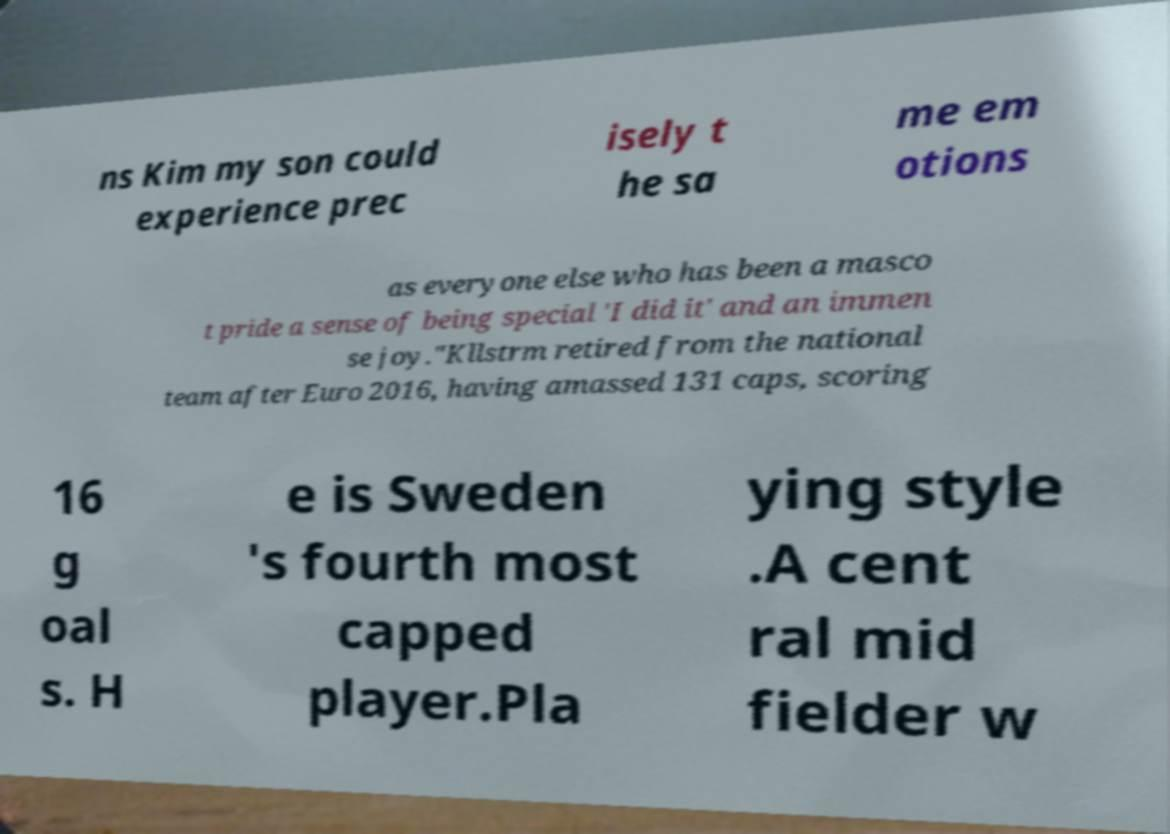Can you read and provide the text displayed in the image?This photo seems to have some interesting text. Can you extract and type it out for me? ns Kim my son could experience prec isely t he sa me em otions as everyone else who has been a masco t pride a sense of being special 'I did it' and an immen se joy."Kllstrm retired from the national team after Euro 2016, having amassed 131 caps, scoring 16 g oal s. H e is Sweden 's fourth most capped player.Pla ying style .A cent ral mid fielder w 